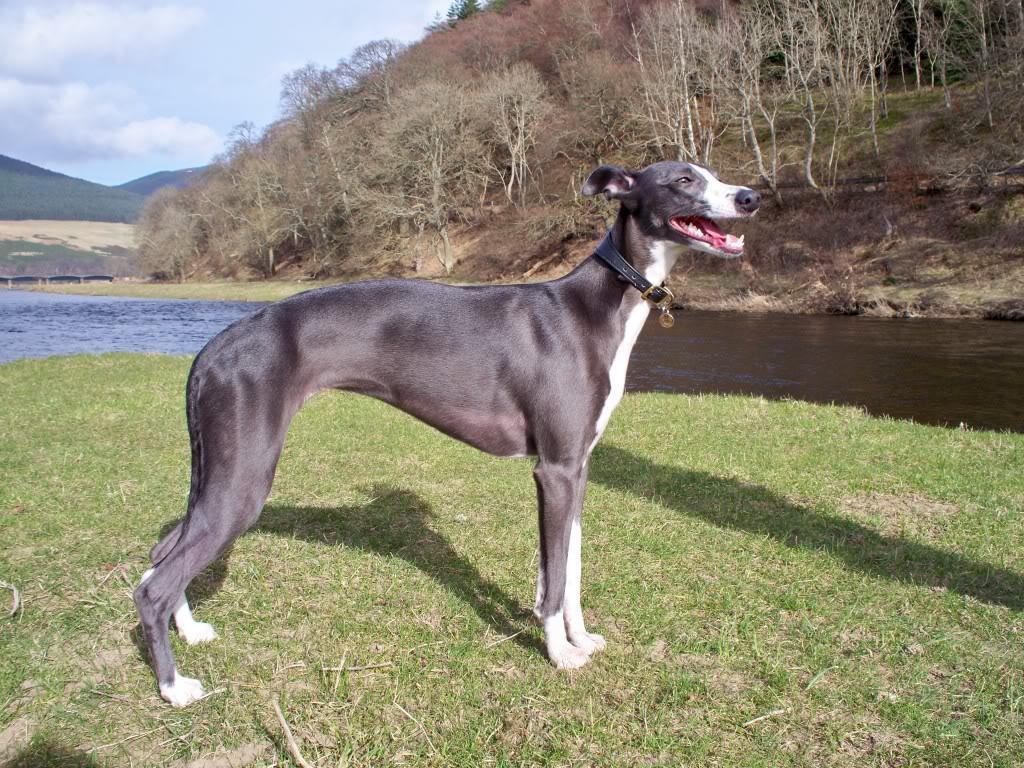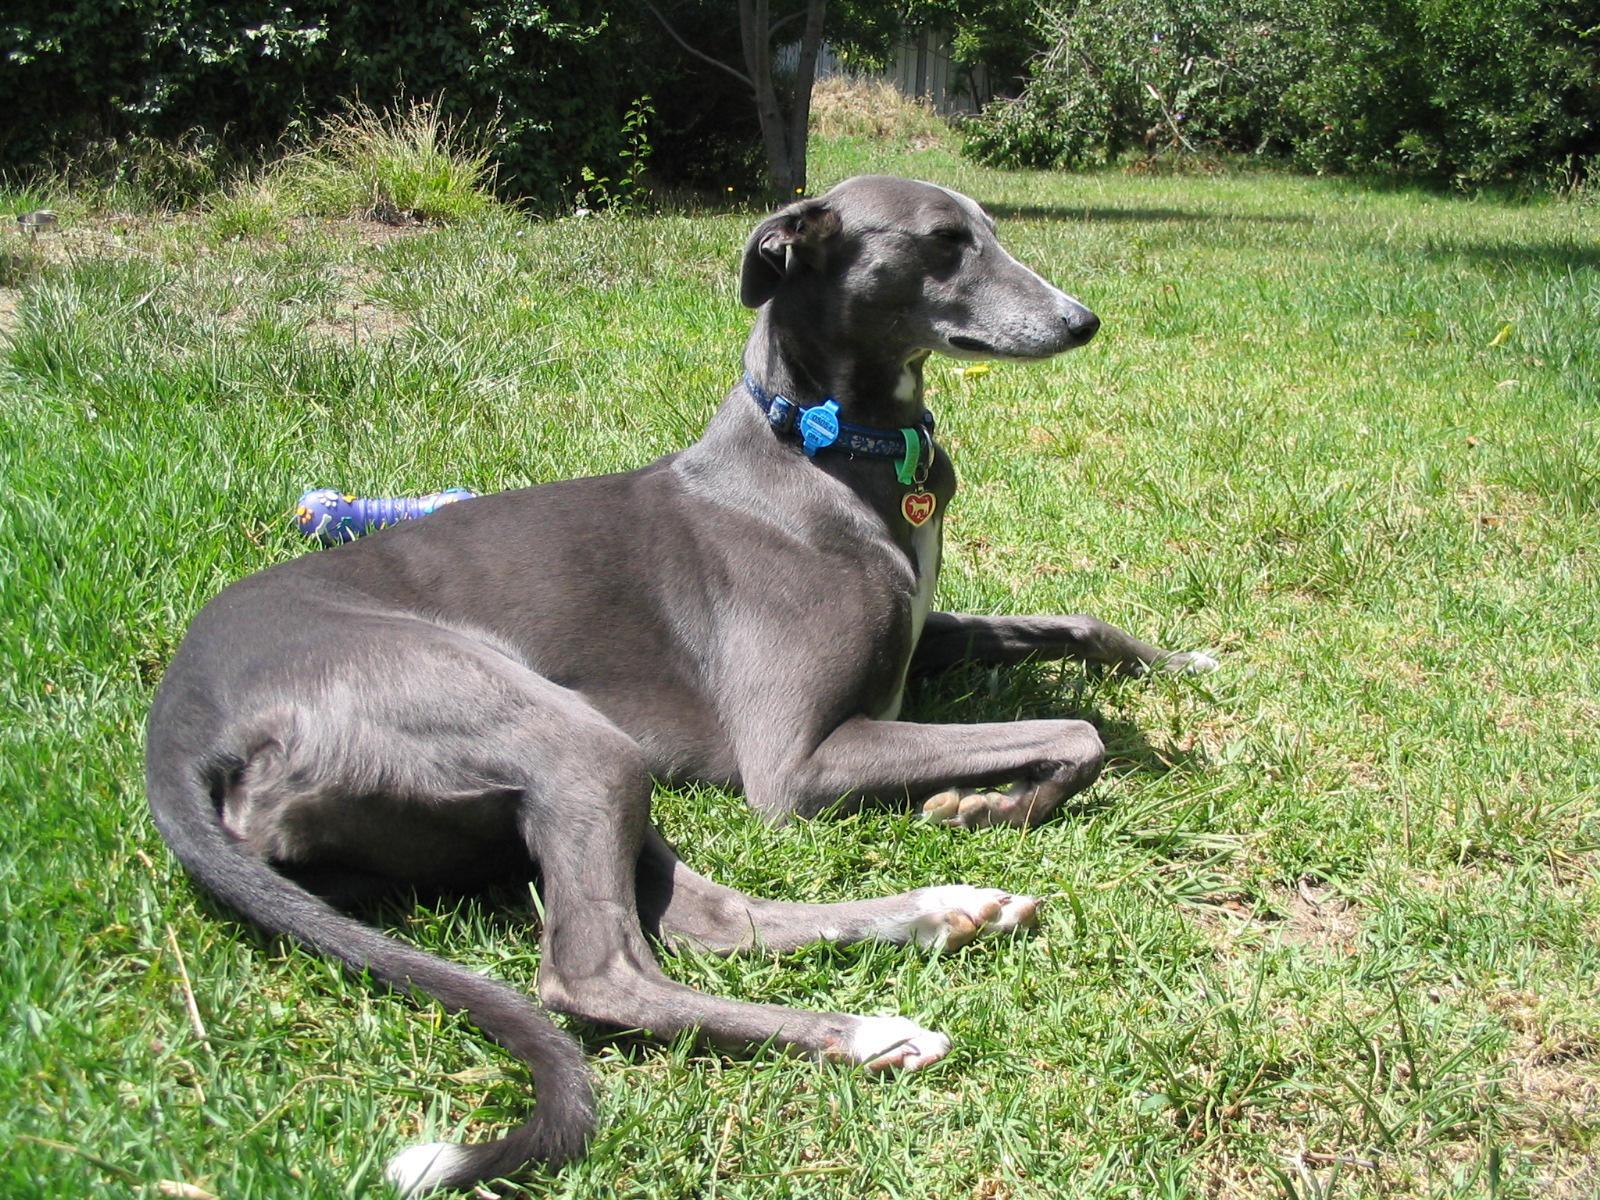The first image is the image on the left, the second image is the image on the right. Given the left and right images, does the statement "The left image contains exactly one dog." hold true? Answer yes or no. Yes. The first image is the image on the left, the second image is the image on the right. Examine the images to the left and right. Is the description "All dogs in the image pair are facing the same direction." accurate? Answer yes or no. Yes. 